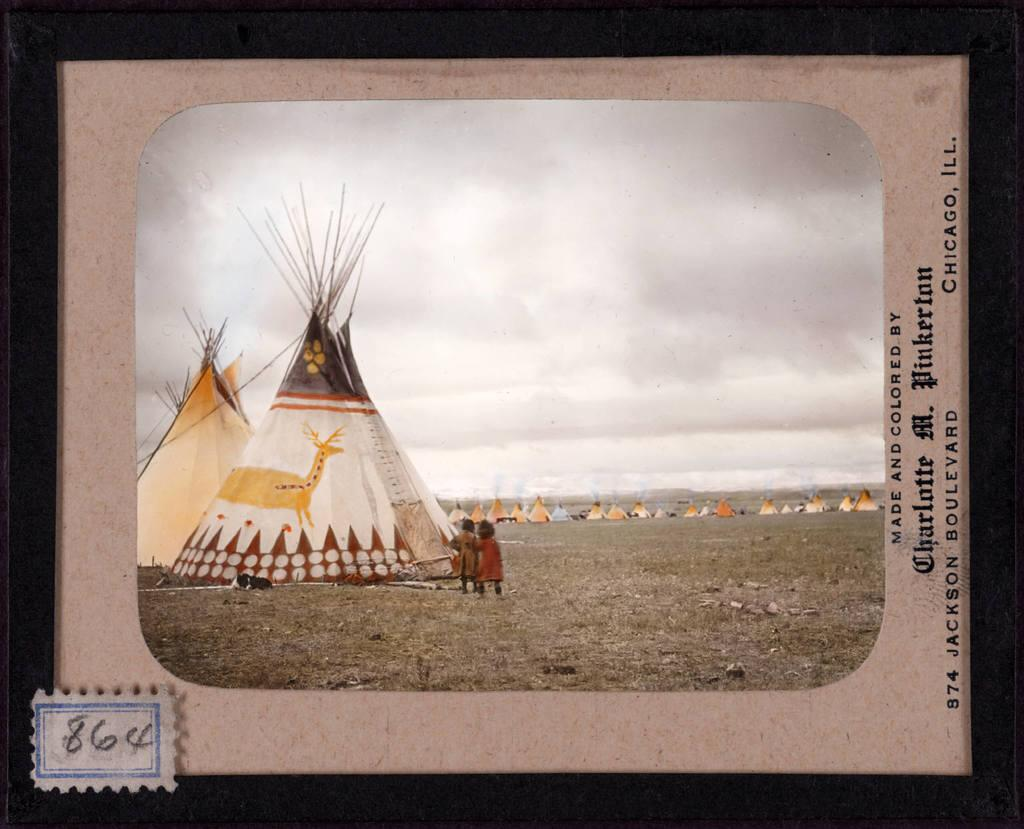What is depicted on the card in the image? There is a painting on a card in the image, and it contains many tents. How many kids are present in the image? There are two kids in the image. What is the condition of the sky in the image? The sky is cloudy in the image. What type of boundary can be seen in the image? There is no boundary present in the image; it features a painting on a card, two kids, and a cloudy sky. Is there a jail visible in the image? There is no jail present in the image. 